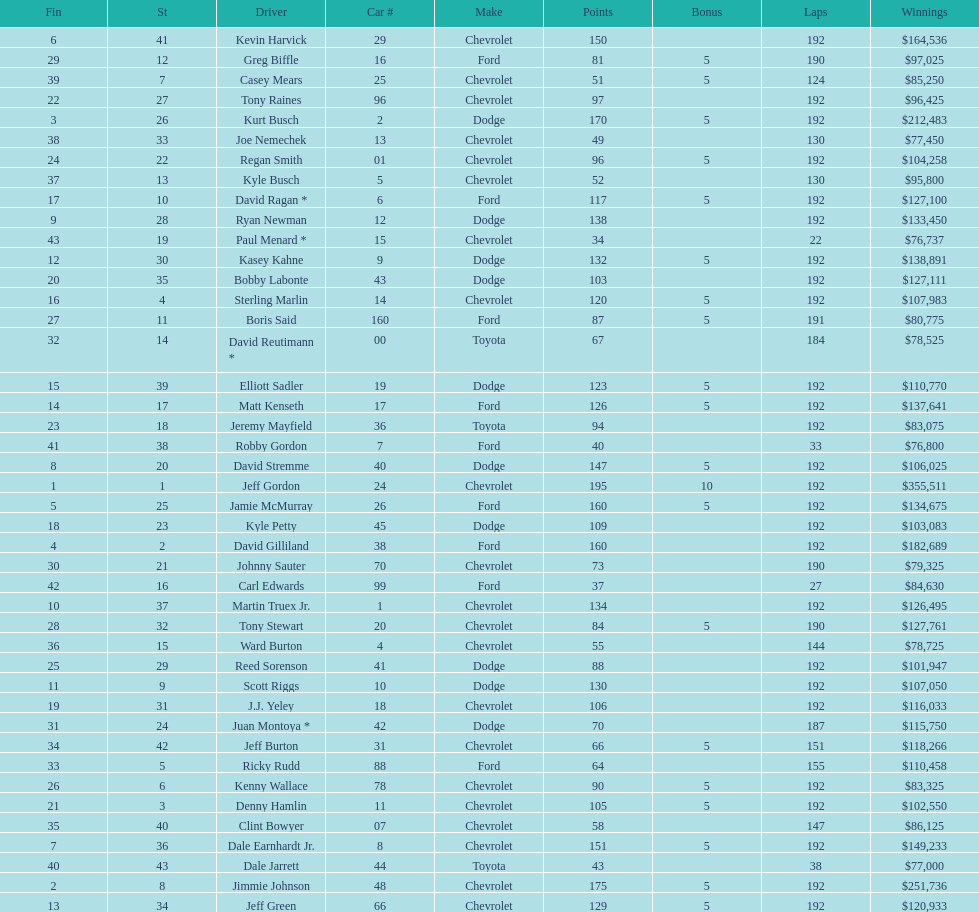What make did kurt busch drive? Dodge. Can you give me this table as a dict? {'header': ['Fin', 'St', 'Driver', 'Car #', 'Make', 'Points', 'Bonus', 'Laps', 'Winnings'], 'rows': [['6', '41', 'Kevin Harvick', '29', 'Chevrolet', '150', '', '192', '$164,536'], ['29', '12', 'Greg Biffle', '16', 'Ford', '81', '5', '190', '$97,025'], ['39', '7', 'Casey Mears', '25', 'Chevrolet', '51', '5', '124', '$85,250'], ['22', '27', 'Tony Raines', '96', 'Chevrolet', '97', '', '192', '$96,425'], ['3', '26', 'Kurt Busch', '2', 'Dodge', '170', '5', '192', '$212,483'], ['38', '33', 'Joe Nemechek', '13', 'Chevrolet', '49', '', '130', '$77,450'], ['24', '22', 'Regan Smith', '01', 'Chevrolet', '96', '5', '192', '$104,258'], ['37', '13', 'Kyle Busch', '5', 'Chevrolet', '52', '', '130', '$95,800'], ['17', '10', 'David Ragan *', '6', 'Ford', '117', '5', '192', '$127,100'], ['9', '28', 'Ryan Newman', '12', 'Dodge', '138', '', '192', '$133,450'], ['43', '19', 'Paul Menard *', '15', 'Chevrolet', '34', '', '22', '$76,737'], ['12', '30', 'Kasey Kahne', '9', 'Dodge', '132', '5', '192', '$138,891'], ['20', '35', 'Bobby Labonte', '43', 'Dodge', '103', '', '192', '$127,111'], ['16', '4', 'Sterling Marlin', '14', 'Chevrolet', '120', '5', '192', '$107,983'], ['27', '11', 'Boris Said', '160', 'Ford', '87', '5', '191', '$80,775'], ['32', '14', 'David Reutimann *', '00', 'Toyota', '67', '', '184', '$78,525'], ['15', '39', 'Elliott Sadler', '19', 'Dodge', '123', '5', '192', '$110,770'], ['14', '17', 'Matt Kenseth', '17', 'Ford', '126', '5', '192', '$137,641'], ['23', '18', 'Jeremy Mayfield', '36', 'Toyota', '94', '', '192', '$83,075'], ['41', '38', 'Robby Gordon', '7', 'Ford', '40', '', '33', '$76,800'], ['8', '20', 'David Stremme', '40', 'Dodge', '147', '5', '192', '$106,025'], ['1', '1', 'Jeff Gordon', '24', 'Chevrolet', '195', '10', '192', '$355,511'], ['5', '25', 'Jamie McMurray', '26', 'Ford', '160', '5', '192', '$134,675'], ['18', '23', 'Kyle Petty', '45', 'Dodge', '109', '', '192', '$103,083'], ['4', '2', 'David Gilliland', '38', 'Ford', '160', '', '192', '$182,689'], ['30', '21', 'Johnny Sauter', '70', 'Chevrolet', '73', '', '190', '$79,325'], ['42', '16', 'Carl Edwards', '99', 'Ford', '37', '', '27', '$84,630'], ['10', '37', 'Martin Truex Jr.', '1', 'Chevrolet', '134', '', '192', '$126,495'], ['28', '32', 'Tony Stewart', '20', 'Chevrolet', '84', '5', '190', '$127,761'], ['36', '15', 'Ward Burton', '4', 'Chevrolet', '55', '', '144', '$78,725'], ['25', '29', 'Reed Sorenson', '41', 'Dodge', '88', '', '192', '$101,947'], ['11', '9', 'Scott Riggs', '10', 'Dodge', '130', '', '192', '$107,050'], ['19', '31', 'J.J. Yeley', '18', 'Chevrolet', '106', '', '192', '$116,033'], ['31', '24', 'Juan Montoya *', '42', 'Dodge', '70', '', '187', '$115,750'], ['34', '42', 'Jeff Burton', '31', 'Chevrolet', '66', '5', '151', '$118,266'], ['33', '5', 'Ricky Rudd', '88', 'Ford', '64', '', '155', '$110,458'], ['26', '6', 'Kenny Wallace', '78', 'Chevrolet', '90', '5', '192', '$83,325'], ['21', '3', 'Denny Hamlin', '11', 'Chevrolet', '105', '5', '192', '$102,550'], ['35', '40', 'Clint Bowyer', '07', 'Chevrolet', '58', '', '147', '$86,125'], ['7', '36', 'Dale Earnhardt Jr.', '8', 'Chevrolet', '151', '5', '192', '$149,233'], ['40', '43', 'Dale Jarrett', '44', 'Toyota', '43', '', '38', '$77,000'], ['2', '8', 'Jimmie Johnson', '48', 'Chevrolet', '175', '5', '192', '$251,736'], ['13', '34', 'Jeff Green', '66', 'Chevrolet', '129', '5', '192', '$120,933']]} 